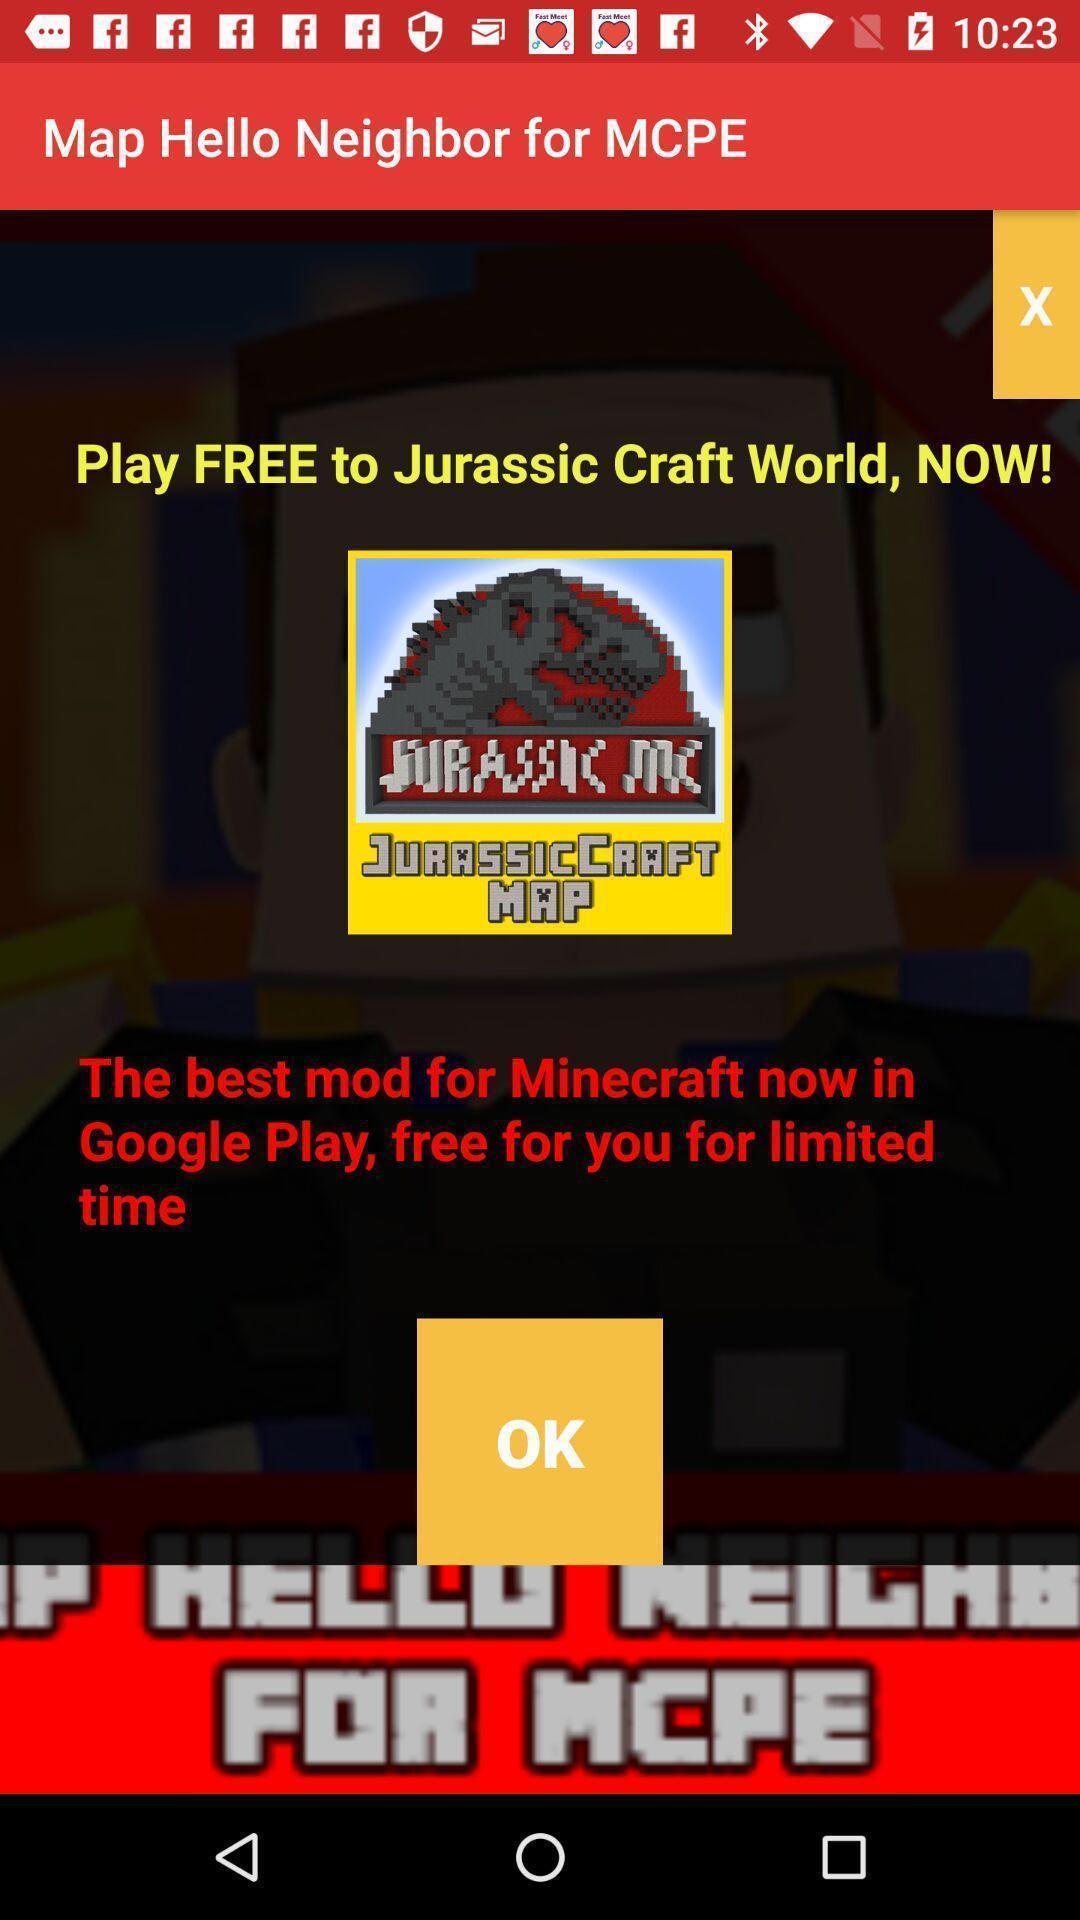Give me a summary of this screen capture. Popup of gaming app to download. 